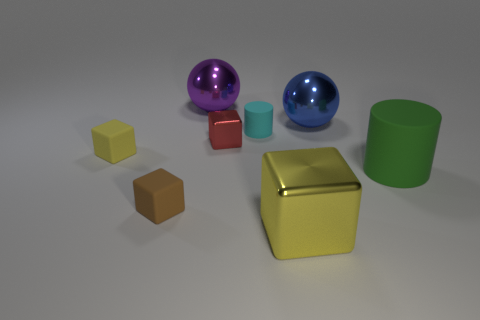The metallic object that is in front of the cylinder in front of the yellow object behind the big green matte cylinder is what color?
Give a very brief answer. Yellow. There is a small matte object that is both behind the green matte object and to the left of the small rubber cylinder; what is its shape?
Provide a succinct answer. Cube. How many other objects are there of the same shape as the small red metallic object?
Offer a terse response. 3. There is a large object in front of the tiny block in front of the large thing that is to the right of the blue metallic ball; what is its shape?
Your answer should be very brief. Cube. What number of things are big green things or things that are on the left side of the large matte cylinder?
Your response must be concise. 8. Do the big metal object that is to the right of the large yellow block and the large thing on the left side of the small cyan matte thing have the same shape?
Give a very brief answer. Yes. What number of objects are either big purple shiny spheres or small cyan matte balls?
Ensure brevity in your answer.  1. Are there any large green metal balls?
Your response must be concise. No. Is the ball to the right of the tiny red cube made of the same material as the tiny red object?
Provide a succinct answer. Yes. Are there any purple metal objects of the same shape as the blue thing?
Your response must be concise. Yes. 